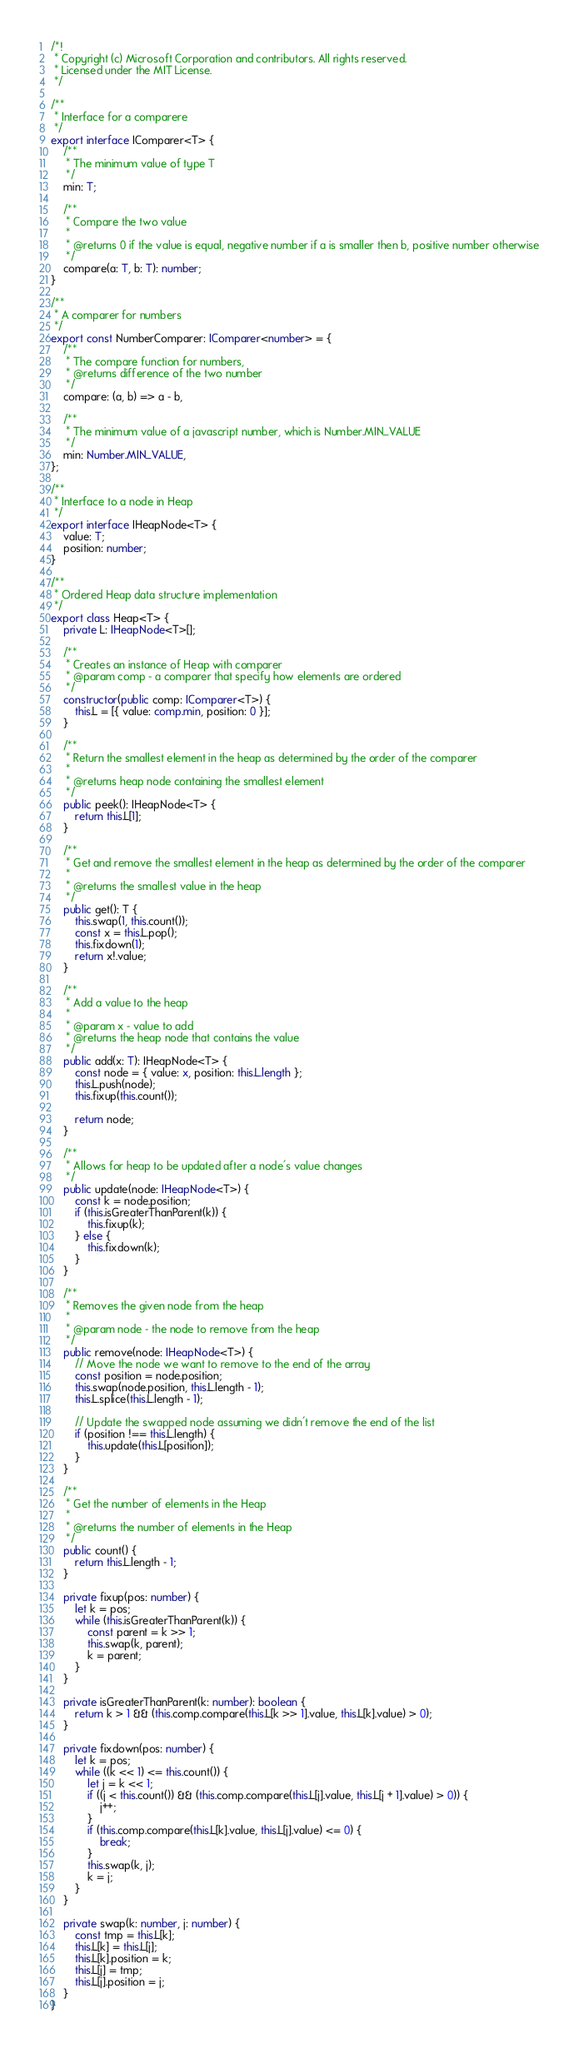Convert code to text. <code><loc_0><loc_0><loc_500><loc_500><_TypeScript_>/*!
 * Copyright (c) Microsoft Corporation and contributors. All rights reserved.
 * Licensed under the MIT License.
 */

/**
 * Interface for a comparere
 */
export interface IComparer<T> {
    /**
     * The minimum value of type T
     */
    min: T;

    /**
     * Compare the two value
     *
     * @returns 0 if the value is equal, negative number if a is smaller then b, positive number otherwise
     */
    compare(a: T, b: T): number;
}

/**
 * A comparer for numbers
 */
export const NumberComparer: IComparer<number> = {
    /**
     * The compare function for numbers,
     * @returns difference of the two number
     */
    compare: (a, b) => a - b,

    /**
     * The minimum value of a javascript number, which is Number.MIN_VALUE
     */
    min: Number.MIN_VALUE,
};

/**
 * Interface to a node in Heap
 */
export interface IHeapNode<T> {
    value: T;
    position: number;
}

/**
 * Ordered Heap data structure implementation
 */
export class Heap<T> {
    private L: IHeapNode<T>[];

    /**
     * Creates an instance of Heap with comparer
     * @param comp - a comparer that specify how elements are ordered
     */
    constructor(public comp: IComparer<T>) {
        this.L = [{ value: comp.min, position: 0 }];
    }

    /**
     * Return the smallest element in the heap as determined by the order of the comparer
     *
     * @returns heap node containing the smallest element
     */
    public peek(): IHeapNode<T> {
        return this.L[1];
    }

    /**
     * Get and remove the smallest element in the heap as determined by the order of the comparer
     *
     * @returns the smallest value in the heap
     */
    public get(): T {
        this.swap(1, this.count());
        const x = this.L.pop();
        this.fixdown(1);
        return x!.value;
    }

    /**
     * Add a value to the heap
     *
     * @param x - value to add
     * @returns the heap node that contains the value
     */
    public add(x: T): IHeapNode<T> {
        const node = { value: x, position: this.L.length };
        this.L.push(node);
        this.fixup(this.count());

        return node;
    }

    /**
     * Allows for heap to be updated after a node's value changes
     */
    public update(node: IHeapNode<T>) {
        const k = node.position;
        if (this.isGreaterThanParent(k)) {
            this.fixup(k);
        } else {
            this.fixdown(k);
        }
    }

    /**
     * Removes the given node from the heap
     *
     * @param node - the node to remove from the heap
     */
    public remove(node: IHeapNode<T>) {
        // Move the node we want to remove to the end of the array
        const position = node.position;
        this.swap(node.position, this.L.length - 1);
        this.L.splice(this.L.length - 1);

        // Update the swapped node assuming we didn't remove the end of the list
        if (position !== this.L.length) {
            this.update(this.L[position]);
        }
    }

    /**
     * Get the number of elements in the Heap
     *
     * @returns the number of elements in the Heap
     */
    public count() {
        return this.L.length - 1;
    }

    private fixup(pos: number) {
        let k = pos;
        while (this.isGreaterThanParent(k)) {
            const parent = k >> 1;
            this.swap(k, parent);
            k = parent;
        }
    }

    private isGreaterThanParent(k: number): boolean {
        return k > 1 && (this.comp.compare(this.L[k >> 1].value, this.L[k].value) > 0);
    }

    private fixdown(pos: number) {
        let k = pos;
        while ((k << 1) <= this.count()) {
            let j = k << 1;
            if ((j < this.count()) && (this.comp.compare(this.L[j].value, this.L[j + 1].value) > 0)) {
                j++;
            }
            if (this.comp.compare(this.L[k].value, this.L[j].value) <= 0) {
                break;
            }
            this.swap(k, j);
            k = j;
        }
    }

    private swap(k: number, j: number) {
        const tmp = this.L[k];
        this.L[k] = this.L[j];
        this.L[k].position = k;
        this.L[j] = tmp;
        this.L[j].position = j;
    }
}
</code> 